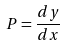Convert formula to latex. <formula><loc_0><loc_0><loc_500><loc_500>P = \frac { d y } { d x }</formula> 